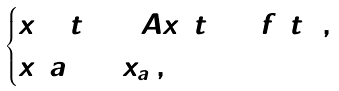<formula> <loc_0><loc_0><loc_500><loc_500>\begin{cases} x ^ { \Delta } ( t ) = A x ( t ) + f ( t ) \, , \\ x ( a ) = x _ { a } \, , \end{cases}</formula> 